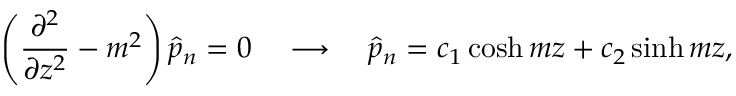Convert formula to latex. <formula><loc_0><loc_0><loc_500><loc_500>\left ( \frac { \partial ^ { 2 } } { \partial z ^ { 2 } } - m ^ { 2 } \right ) \hat { p } _ { n } = 0 \quad l o n g r i g h t a r r o w \quad h a t { p } _ { n } = c _ { 1 } \cosh { m z } + c _ { 2 } \sinh { m z } ,</formula> 